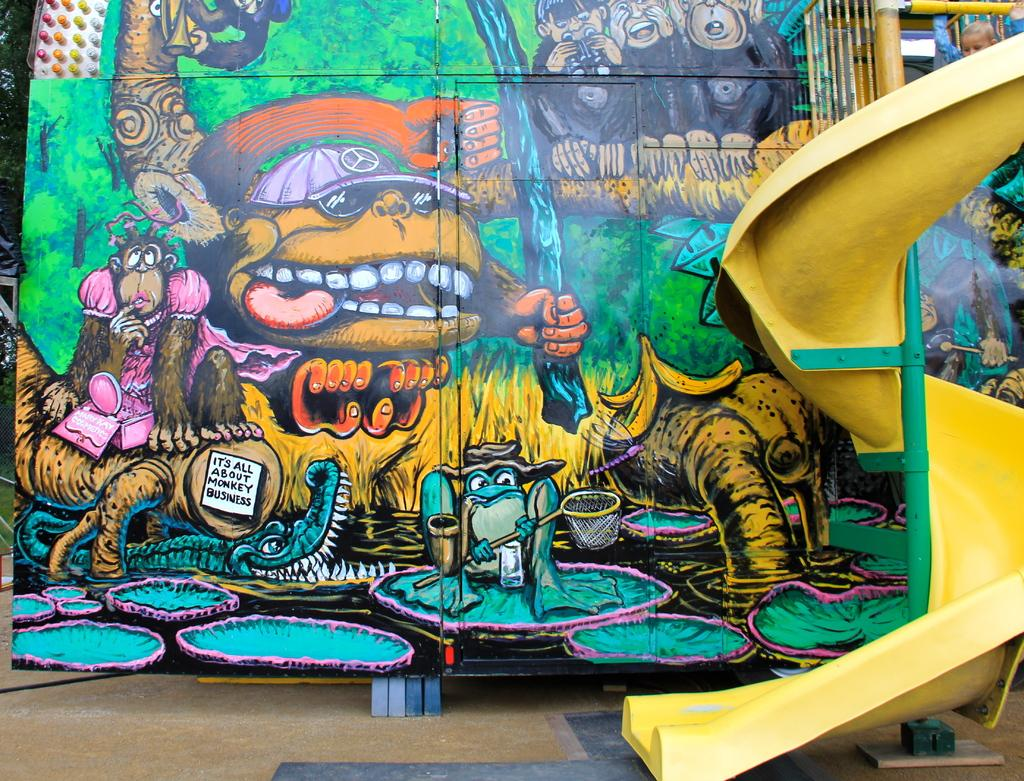What is the main subject of the image? The image contains a painting. What is being depicted in the painting? The painting depicts animals and trees. Are there any other elements in the painting besides animals and trees? Yes, there are objects present in the painting. What can be seen at the left side of the image? There are trees at the left side of the image. What type of books can be seen on the judge's desk in the image? There is no judge or desk present in the image; it features a painting with animals, trees, and objects. 